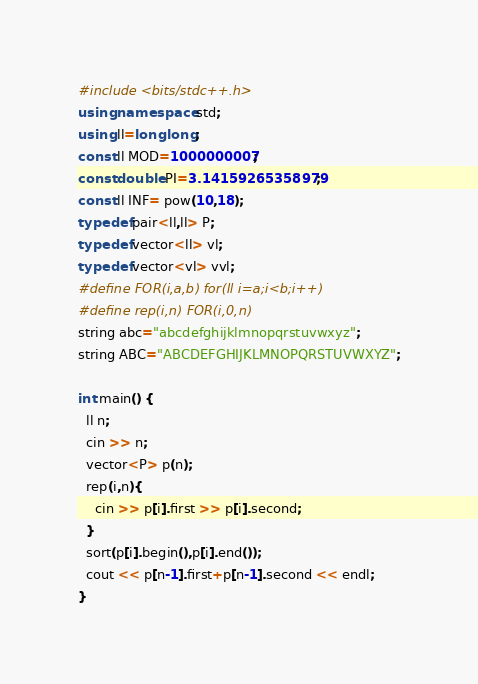<code> <loc_0><loc_0><loc_500><loc_500><_C++_>#include <bits/stdc++.h>
using namespace std;
using ll=long long;
const ll MOD=1000000007;
const double PI=3.14159265358979;
const ll INF= pow(10,18);
typedef pair<ll,ll> P;
typedef vector<ll> vl;
typedef vector<vl> vvl;
#define FOR(i,a,b) for(ll i=a;i<b;i++)
#define rep(i,n) FOR(i,0,n)
string abc="abcdefghijklmnopqrstuvwxyz";
string ABC="ABCDEFGHIJKLMNOPQRSTUVWXYZ";

int main() {
  ll n;
  cin >> n;
  vector<P> p(n);
  rep(i,n){
    cin >> p[i].first >> p[i].second;
  }
  sort(p[i].begin(),p[i].end());
  cout << p[n-1].first+p[n-1].second << endl;
}</code> 